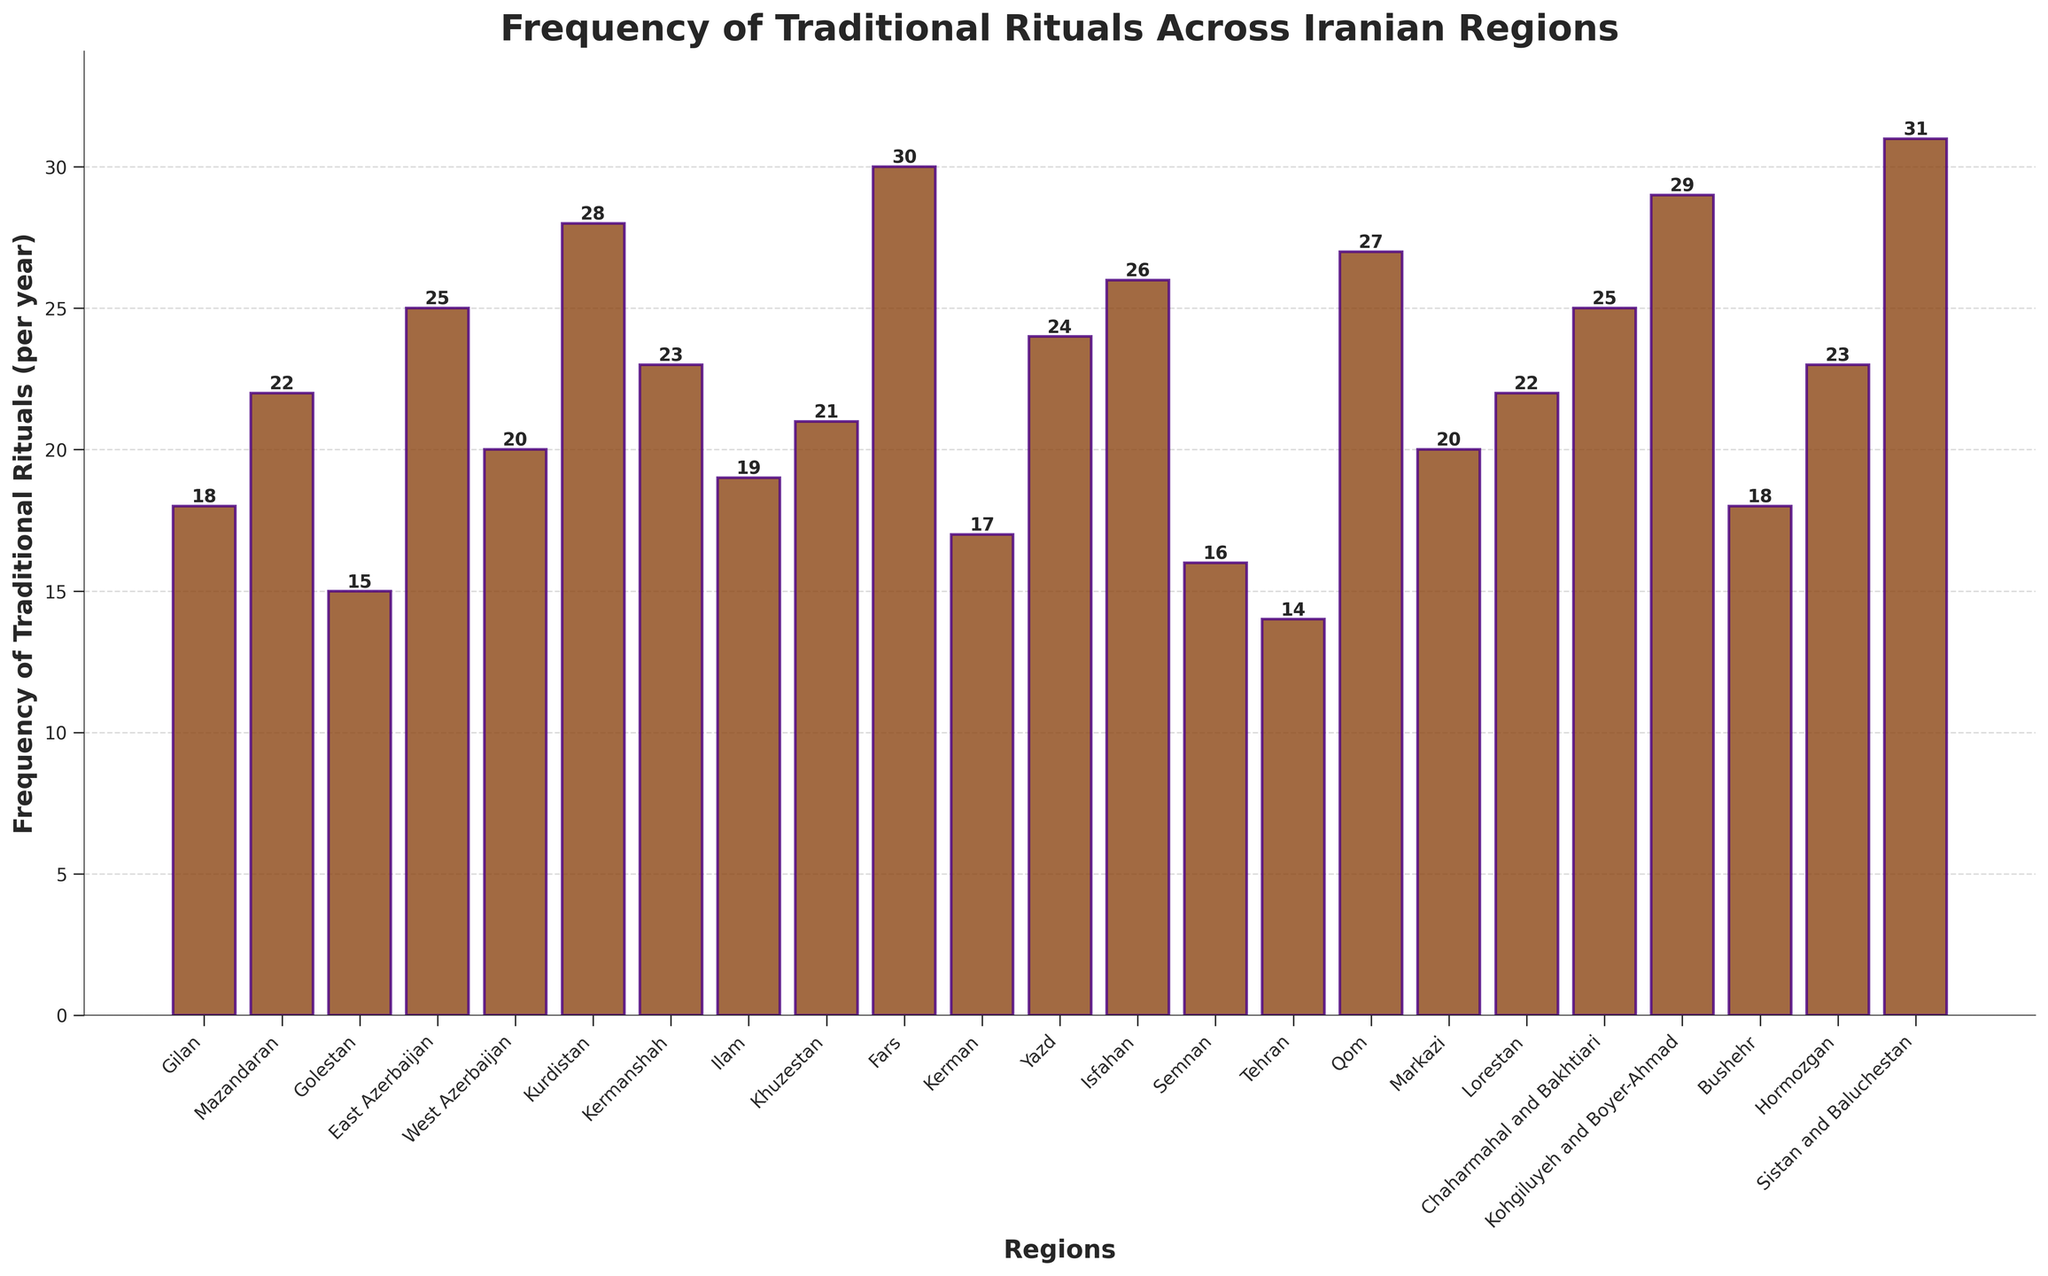Which region has the highest frequency of traditional rituals? Locate the highest bar in the chart, which represents the region with the most rituals performed per year.
Answer: Sistan and Baluchestan How does the frequency of traditional rituals in Tehran compare to Kermanshah? Check the heights of the bars for Tehran and Kermanshah. The bar for Tehran is lower than the bar for Kermanshah, indicating that Tehran performs fewer rituals.
Answer: Tehran has fewer Which regions have a frequency of 25 traditional rituals per year? Identify the bars that have a height of 25 and then read the corresponding region labels.
Answer: East Azerbaijan, Chaharmahal and Bakhtiari What is the average frequency of traditional rituals performed in Ilam, Yazd, and Markazi? Determine the heights of the bars for Ilam, Yazd, and Markazi, then calculate the average: (19 + 24 + 20) / 3.
Answer: 21 Which region performs more traditional rituals per year, Fars or Qom? Compare the heights of the bars for Fars and Qom. The taller bar corresponds to the region with more rituals.
Answer: Fars Calculate the difference in the frequency of traditional rituals between Mazandaran and Golestan. Subtract the height of the Golestan bar from the Mazandaran bar: 22 - 15.
Answer: 7 What is the total frequency of traditional rituals performed in the provinces beginning with 'K'? Sum the heights of the bars for provinces starting with 'K': Kurdistan (28), Kermanshah (23), Kerman (17), Khuzestan (21), and Kohgiluyeh and Boyer-Ahmad (29). The total is 28 + 23 + 17 + 21 + 29.
Answer: 118 Are there any regions with the same frequency of traditional rituals performed per year? If so, name them. Check for regions whose bars have the same height. Yes, Markazi and West Azerbaijan both perform 20 rituals per year.
Answer: Markazi and West Azerbaijan Which region has the lowest frequency of traditional rituals, and what is this frequency? Locate the shortest bar on the chart and identify the corresponding region and its frequency.
Answer: Tehran with 14 